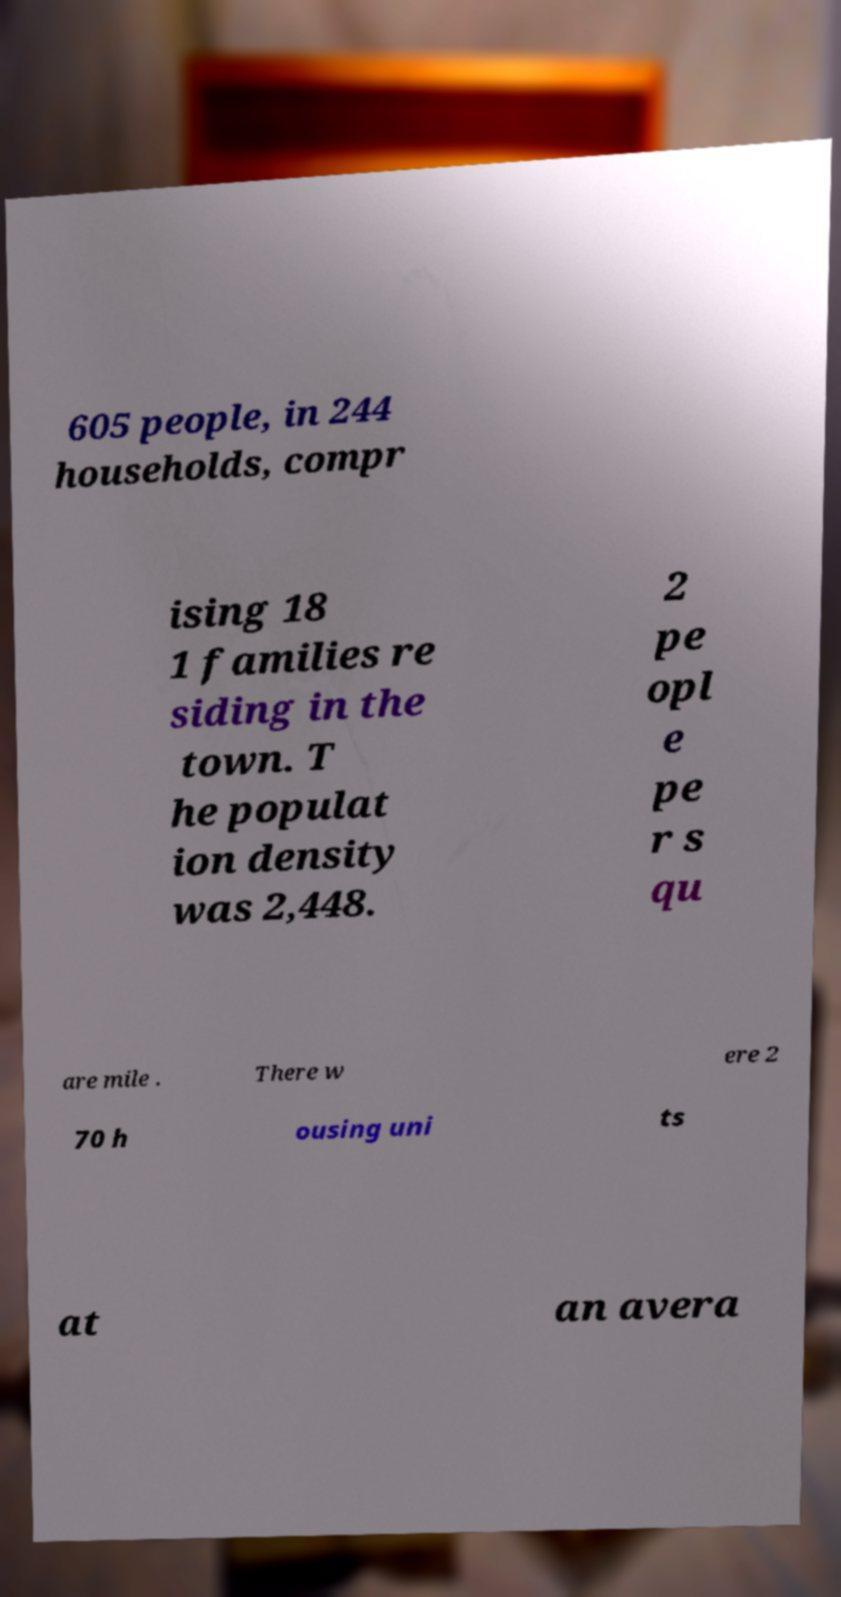There's text embedded in this image that I need extracted. Can you transcribe it verbatim? 605 people, in 244 households, compr ising 18 1 families re siding in the town. T he populat ion density was 2,448. 2 pe opl e pe r s qu are mile . There w ere 2 70 h ousing uni ts at an avera 